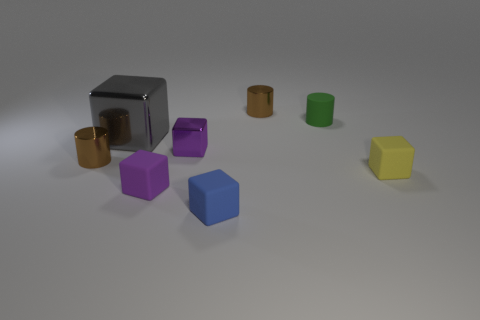Subtract all small purple metal blocks. How many blocks are left? 4 Subtract all cyan cylinders. How many purple blocks are left? 2 Subtract all gray blocks. How many blocks are left? 4 Add 2 small purple metallic objects. How many objects exist? 10 Subtract all purple cylinders. Subtract all yellow blocks. How many cylinders are left? 3 Subtract all small purple metal cubes. Subtract all big gray blocks. How many objects are left? 6 Add 4 tiny rubber things. How many tiny rubber things are left? 8 Add 1 gray blocks. How many gray blocks exist? 2 Subtract 0 gray balls. How many objects are left? 8 Subtract all blocks. How many objects are left? 3 